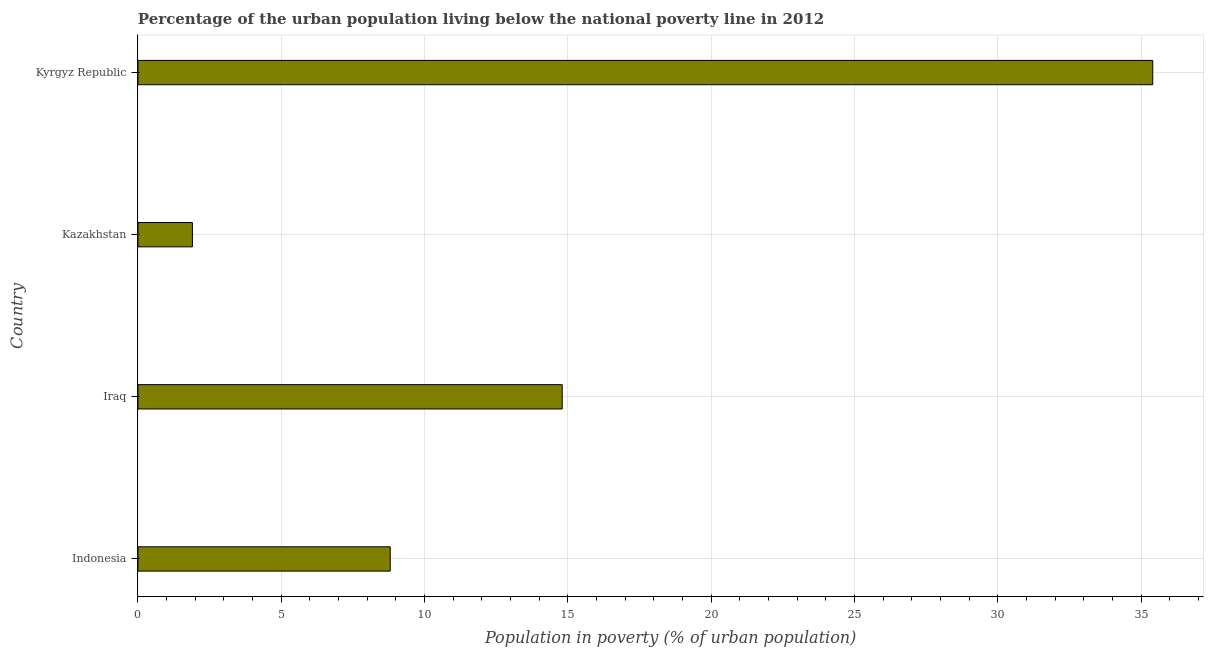Does the graph contain grids?
Offer a very short reply. Yes. What is the title of the graph?
Your answer should be very brief. Percentage of the urban population living below the national poverty line in 2012. What is the label or title of the X-axis?
Your response must be concise. Population in poverty (% of urban population). What is the label or title of the Y-axis?
Ensure brevity in your answer.  Country. Across all countries, what is the maximum percentage of urban population living below poverty line?
Your response must be concise. 35.4. Across all countries, what is the minimum percentage of urban population living below poverty line?
Make the answer very short. 1.9. In which country was the percentage of urban population living below poverty line maximum?
Provide a short and direct response. Kyrgyz Republic. In which country was the percentage of urban population living below poverty line minimum?
Make the answer very short. Kazakhstan. What is the sum of the percentage of urban population living below poverty line?
Your response must be concise. 60.9. What is the difference between the percentage of urban population living below poverty line in Iraq and Kyrgyz Republic?
Your answer should be compact. -20.6. What is the average percentage of urban population living below poverty line per country?
Your answer should be very brief. 15.22. What is the median percentage of urban population living below poverty line?
Make the answer very short. 11.8. What is the ratio of the percentage of urban population living below poverty line in Iraq to that in Kyrgyz Republic?
Your answer should be very brief. 0.42. Is the difference between the percentage of urban population living below poverty line in Indonesia and Iraq greater than the difference between any two countries?
Keep it short and to the point. No. What is the difference between the highest and the second highest percentage of urban population living below poverty line?
Your answer should be very brief. 20.6. What is the difference between the highest and the lowest percentage of urban population living below poverty line?
Provide a short and direct response. 33.5. In how many countries, is the percentage of urban population living below poverty line greater than the average percentage of urban population living below poverty line taken over all countries?
Your answer should be compact. 1. How many bars are there?
Your response must be concise. 4. Are all the bars in the graph horizontal?
Ensure brevity in your answer.  Yes. How many countries are there in the graph?
Provide a short and direct response. 4. Are the values on the major ticks of X-axis written in scientific E-notation?
Provide a short and direct response. No. What is the Population in poverty (% of urban population) of Indonesia?
Offer a very short reply. 8.8. What is the Population in poverty (% of urban population) in Kazakhstan?
Provide a short and direct response. 1.9. What is the Population in poverty (% of urban population) of Kyrgyz Republic?
Provide a succinct answer. 35.4. What is the difference between the Population in poverty (% of urban population) in Indonesia and Kyrgyz Republic?
Provide a succinct answer. -26.6. What is the difference between the Population in poverty (% of urban population) in Iraq and Kazakhstan?
Make the answer very short. 12.9. What is the difference between the Population in poverty (% of urban population) in Iraq and Kyrgyz Republic?
Your answer should be compact. -20.6. What is the difference between the Population in poverty (% of urban population) in Kazakhstan and Kyrgyz Republic?
Ensure brevity in your answer.  -33.5. What is the ratio of the Population in poverty (% of urban population) in Indonesia to that in Iraq?
Your answer should be very brief. 0.59. What is the ratio of the Population in poverty (% of urban population) in Indonesia to that in Kazakhstan?
Your answer should be compact. 4.63. What is the ratio of the Population in poverty (% of urban population) in Indonesia to that in Kyrgyz Republic?
Your response must be concise. 0.25. What is the ratio of the Population in poverty (% of urban population) in Iraq to that in Kazakhstan?
Your response must be concise. 7.79. What is the ratio of the Population in poverty (% of urban population) in Iraq to that in Kyrgyz Republic?
Your response must be concise. 0.42. What is the ratio of the Population in poverty (% of urban population) in Kazakhstan to that in Kyrgyz Republic?
Provide a short and direct response. 0.05. 